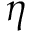Convert formula to latex. <formula><loc_0><loc_0><loc_500><loc_500>\eta</formula> 